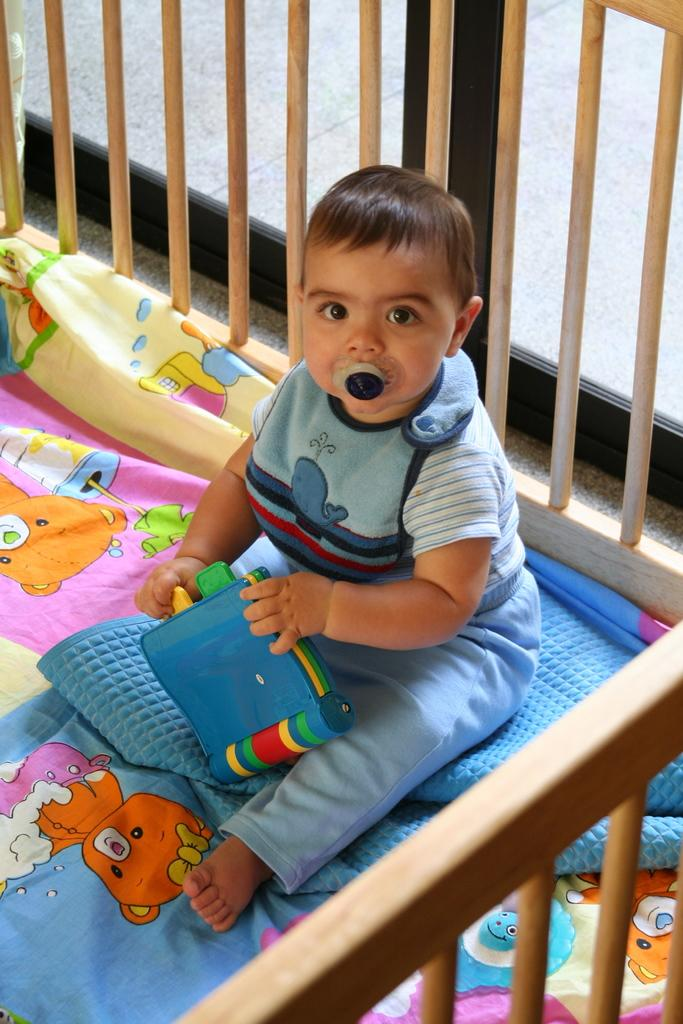What is the main subject of the image? There is a baby in the image. What is the baby holding in the image? The baby is holding an object that looks like a toy. What type of furniture is present in the image? There is a baby bed in the image. What is covering the baby bed? The baby bed has a bed sheet. What is depicted on the bed sheet? The bed sheet has cartoon images on it. What type of system is the baby using to communicate with the crook in the image? There is no crook present in the image, and the baby is not using any system to communicate. How deep are the roots of the plant in the image? There is no plant present in the image, so the depth of its roots cannot be determined. 